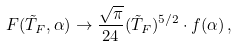Convert formula to latex. <formula><loc_0><loc_0><loc_500><loc_500>F ( \tilde { T } _ { F } , \alpha ) \to \frac { \sqrt { \pi } } { 2 4 } ( \tilde { T } _ { F } ) ^ { 5 / 2 } \cdot f ( \alpha ) \, ,</formula> 